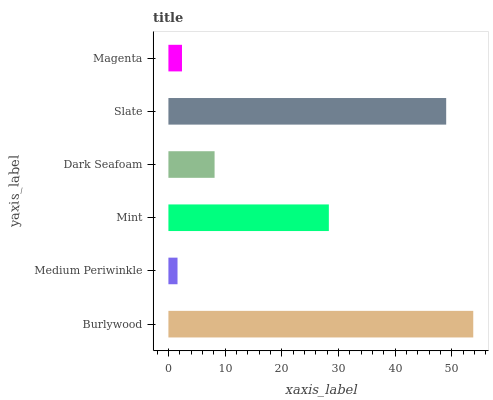Is Medium Periwinkle the minimum?
Answer yes or no. Yes. Is Burlywood the maximum?
Answer yes or no. Yes. Is Mint the minimum?
Answer yes or no. No. Is Mint the maximum?
Answer yes or no. No. Is Mint greater than Medium Periwinkle?
Answer yes or no. Yes. Is Medium Periwinkle less than Mint?
Answer yes or no. Yes. Is Medium Periwinkle greater than Mint?
Answer yes or no. No. Is Mint less than Medium Periwinkle?
Answer yes or no. No. Is Mint the high median?
Answer yes or no. Yes. Is Dark Seafoam the low median?
Answer yes or no. Yes. Is Dark Seafoam the high median?
Answer yes or no. No. Is Slate the low median?
Answer yes or no. No. 